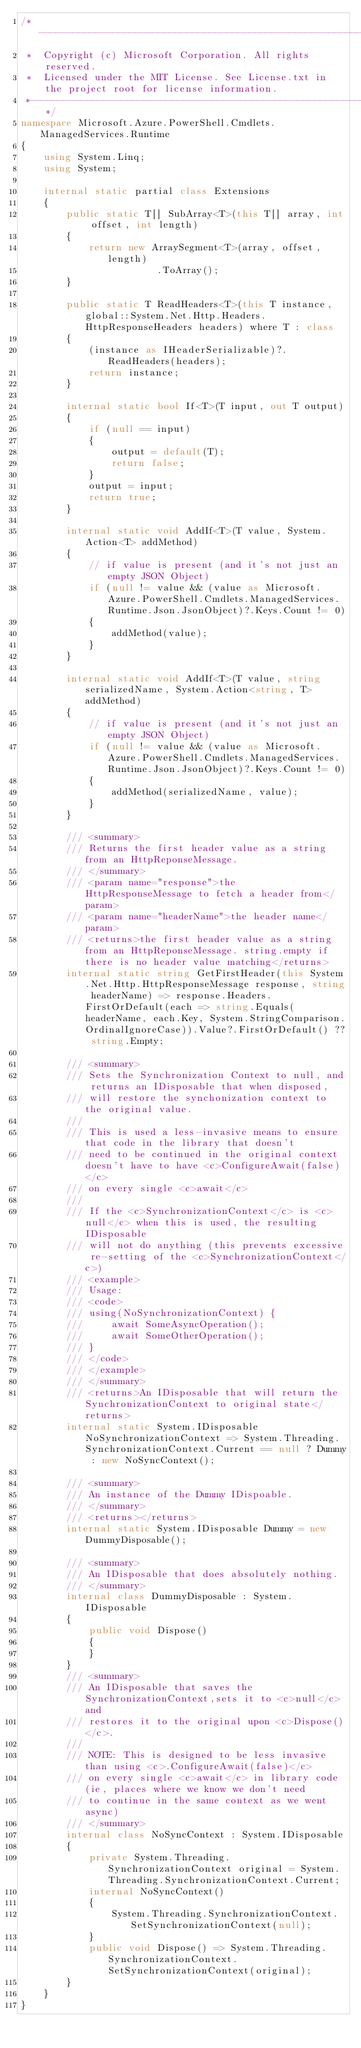Convert code to text. <code><loc_0><loc_0><loc_500><loc_500><_C#_>/*---------------------------------------------------------------------------------------------
 *  Copyright (c) Microsoft Corporation. All rights reserved.
 *  Licensed under the MIT License. See License.txt in the project root for license information.
 *--------------------------------------------------------------------------------------------*/
namespace Microsoft.Azure.PowerShell.Cmdlets.ManagedServices.Runtime
{
    using System.Linq;
    using System;

    internal static partial class Extensions
    {
        public static T[] SubArray<T>(this T[] array, int offset, int length)
        {
            return new ArraySegment<T>(array, offset, length)
                        .ToArray();
        }

        public static T ReadHeaders<T>(this T instance, global::System.Net.Http.Headers.HttpResponseHeaders headers) where T : class
        {
            (instance as IHeaderSerializable)?.ReadHeaders(headers);
            return instance;
        }

        internal static bool If<T>(T input, out T output)
        {
            if (null == input)
            {
                output = default(T);
                return false;
            }
            output = input;
            return true;
        }

        internal static void AddIf<T>(T value, System.Action<T> addMethod)
        {
            // if value is present (and it's not just an empty JSON Object)
            if (null != value && (value as Microsoft.Azure.PowerShell.Cmdlets.ManagedServices.Runtime.Json.JsonObject)?.Keys.Count != 0)
            {
                addMethod(value);
            }
        }

        internal static void AddIf<T>(T value, string serializedName, System.Action<string, T> addMethod)
        {
            // if value is present (and it's not just an empty JSON Object)
            if (null != value && (value as Microsoft.Azure.PowerShell.Cmdlets.ManagedServices.Runtime.Json.JsonObject)?.Keys.Count != 0)
            {
                addMethod(serializedName, value);
            }
        }

        /// <summary>
        /// Returns the first header value as a string from an HttpReponseMessage. 
        /// </summary>
        /// <param name="response">the HttpResponseMessage to fetch a header from</param>
        /// <param name="headerName">the header name</param>
        /// <returns>the first header value as a string from an HttpReponseMessage. string.empty if there is no header value matching</returns>
        internal static string GetFirstHeader(this System.Net.Http.HttpResponseMessage response, string headerName) => response.Headers.FirstOrDefault(each => string.Equals(headerName, each.Key, System.StringComparison.OrdinalIgnoreCase)).Value?.FirstOrDefault() ?? string.Empty;

        /// <summary>
        /// Sets the Synchronization Context to null, and returns an IDisposable that when disposed, 
        /// will restore the synchonization context to the original value.
        /// 
        /// This is used a less-invasive means to ensure that code in the library that doesn't 
        /// need to be continued in the original context doesn't have to have <c>ConfigureAwait(false)</c> 
        /// on every single <c>await</c>
        /// 
        /// If the <c>SynchronizationContext</c> is <c>null</c> when this is used, the resulting IDisposable
        /// will not do anything (this prevents excessive re-setting of the <c>SynchronizationContext</c>)
        /// <example>
        /// Usage:
        /// <code>
        /// using(NoSynchronizationContext) {
        ///     await SomeAsyncOperation();
        ///     await SomeOtherOperation();
        /// }
        /// </code>
        /// </example>
        /// </summary>
        /// <returns>An IDisposable that will return the SynchronizationContext to original state</returns>
        internal static System.IDisposable NoSynchronizationContext => System.Threading.SynchronizationContext.Current == null ? Dummy : new NoSyncContext();

        /// <summary>
        /// An instance of the Dummy IDispoable.
        /// </summary>
        /// <returns></returns>
        internal static System.IDisposable Dummy = new DummyDisposable();

        /// <summary>
        /// An IDisposable that does absolutely nothing. 
        /// </summary>
        internal class DummyDisposable : System.IDisposable
        {
            public void Dispose()
            {
            }
        }
        /// <summary>
        /// An IDisposable that saves the SynchronizationContext,sets it to <c>null</c> and 
        /// restores it to the original upon <c>Dispose()</c>. 
        /// 
        /// NOTE: This is designed to be less invasive than using <c>.ConfigureAwait(false)</c> 
        /// on every single <c>await</c> in library code (ie, places where we know we don't need
        /// to continue in the same context as we went async)
        /// </summary>
        internal class NoSyncContext : System.IDisposable
        {
            private System.Threading.SynchronizationContext original = System.Threading.SynchronizationContext.Current;
            internal NoSyncContext()
            {
                System.Threading.SynchronizationContext.SetSynchronizationContext(null);
            }
            public void Dispose() => System.Threading.SynchronizationContext.SetSynchronizationContext(original);
        }
    }
}</code> 